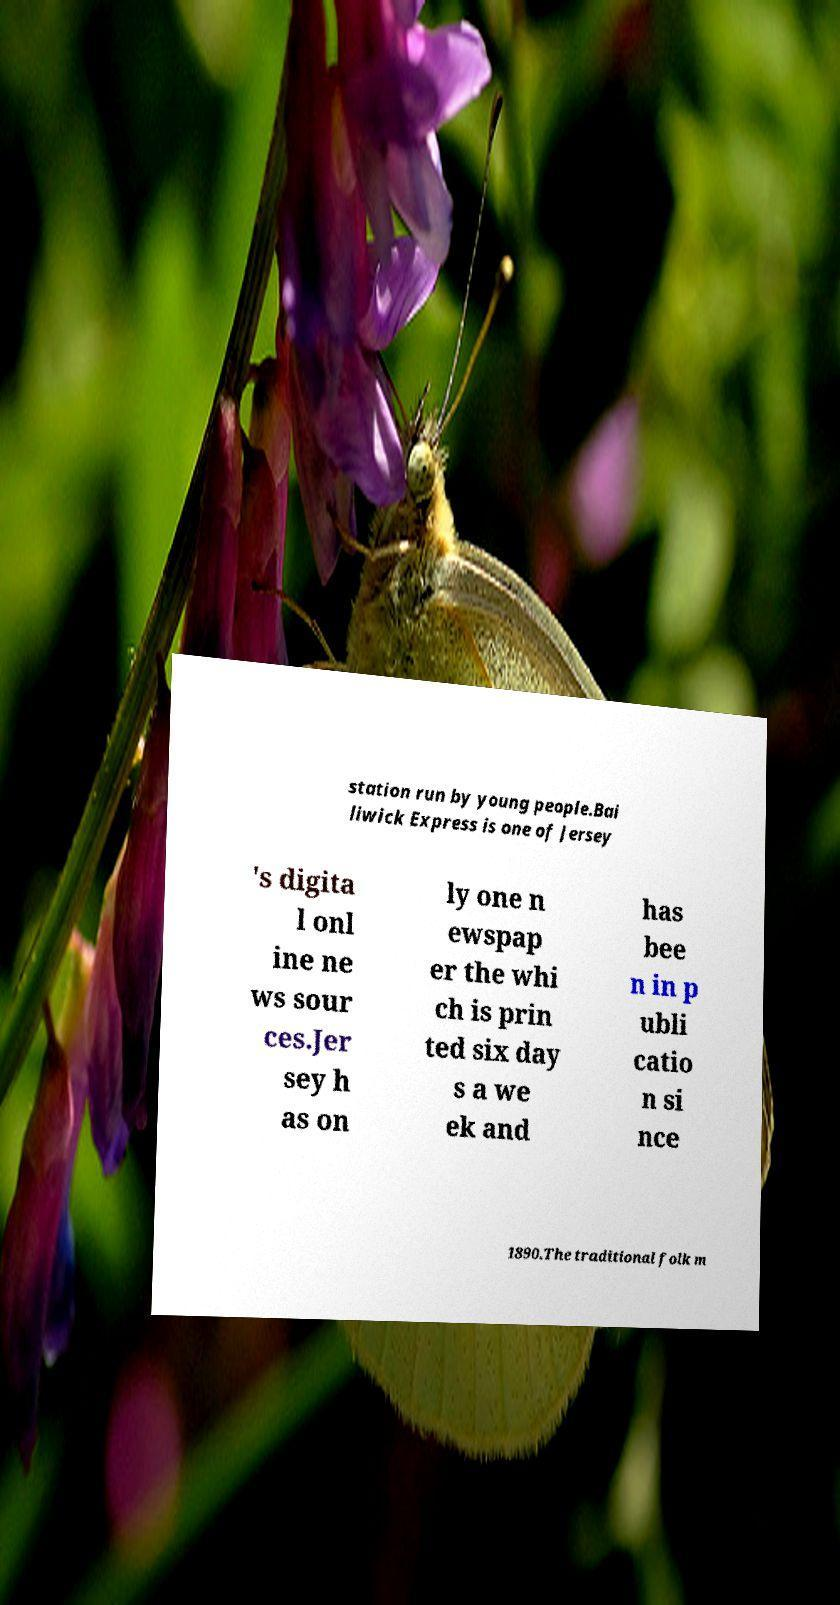Please read and relay the text visible in this image. What does it say? station run by young people.Bai liwick Express is one of Jersey 's digita l onl ine ne ws sour ces.Jer sey h as on ly one n ewspap er the whi ch is prin ted six day s a we ek and has bee n in p ubli catio n si nce 1890.The traditional folk m 